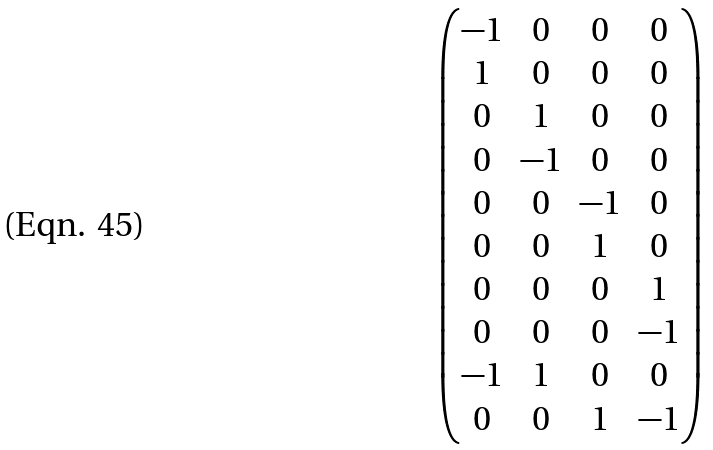Convert formula to latex. <formula><loc_0><loc_0><loc_500><loc_500>\begin{pmatrix} - 1 & 0 & 0 & 0 \\ 1 & 0 & 0 & 0 \\ 0 & 1 & 0 & 0 \\ 0 & - 1 & 0 & 0 \\ 0 & 0 & - 1 & 0 \\ 0 & 0 & 1 & 0 \\ 0 & 0 & 0 & 1 \\ 0 & 0 & 0 & - 1 \\ - 1 & 1 & 0 & 0 \\ 0 & 0 & 1 & - 1 \end{pmatrix}</formula> 